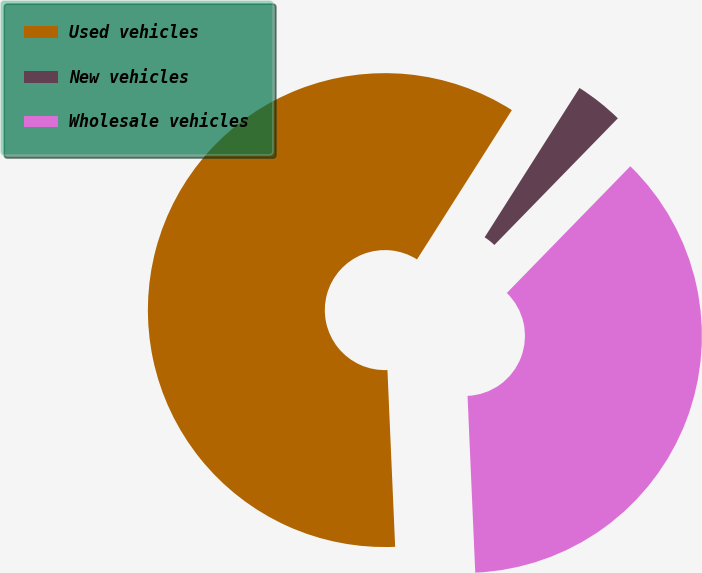Convert chart to OTSL. <chart><loc_0><loc_0><loc_500><loc_500><pie_chart><fcel>Used vehicles<fcel>New vehicles<fcel>Wholesale vehicles<nl><fcel>59.7%<fcel>3.29%<fcel>37.01%<nl></chart> 